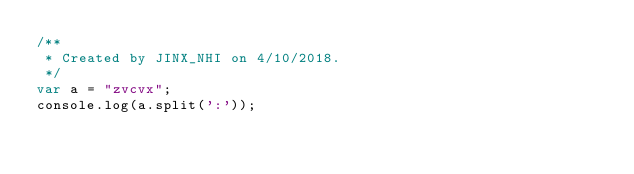<code> <loc_0><loc_0><loc_500><loc_500><_JavaScript_>/**
 * Created by JINX_NHI on 4/10/2018.
 */
var a = "zvcvx";
console.log(a.split(':'));</code> 